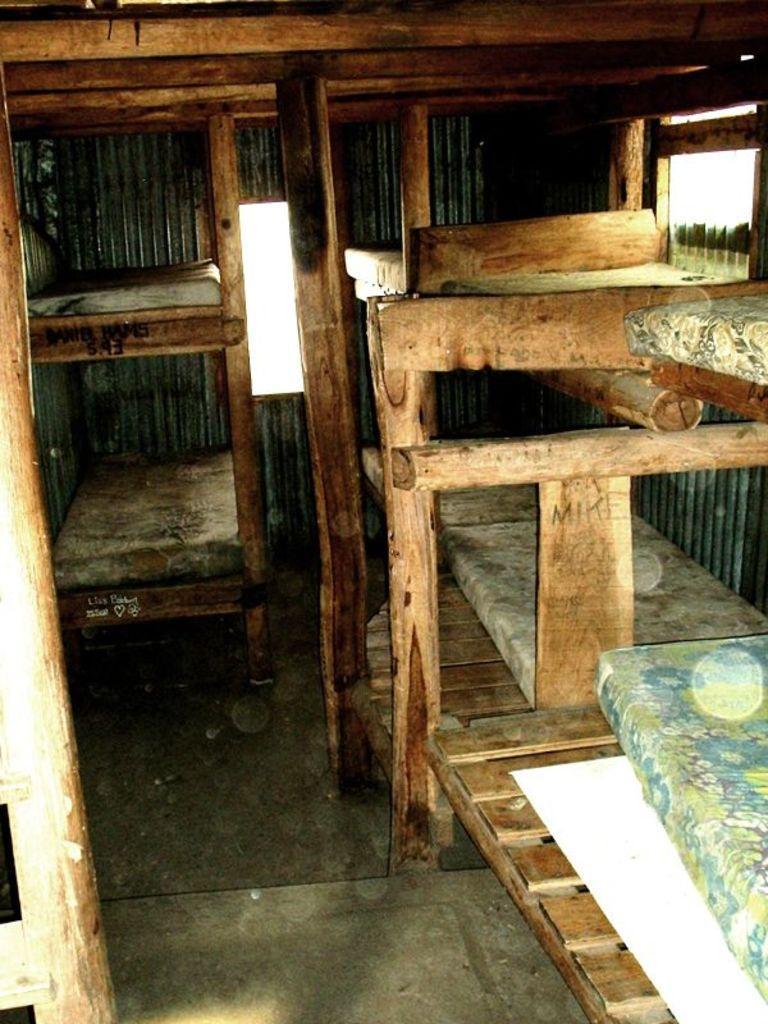Please provide a concise description of this image. In this picture, we see a cot and wooden poles. In the right top of the picture, we see a window. This picture might be clicked in the wooden shed. 